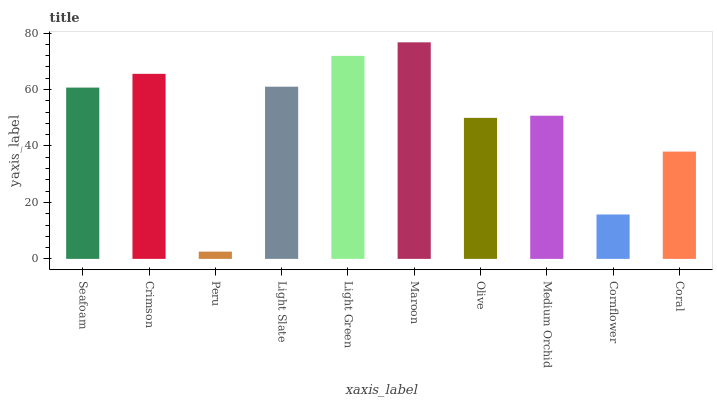Is Peru the minimum?
Answer yes or no. Yes. Is Maroon the maximum?
Answer yes or no. Yes. Is Crimson the minimum?
Answer yes or no. No. Is Crimson the maximum?
Answer yes or no. No. Is Crimson greater than Seafoam?
Answer yes or no. Yes. Is Seafoam less than Crimson?
Answer yes or no. Yes. Is Seafoam greater than Crimson?
Answer yes or no. No. Is Crimson less than Seafoam?
Answer yes or no. No. Is Seafoam the high median?
Answer yes or no. Yes. Is Medium Orchid the low median?
Answer yes or no. Yes. Is Maroon the high median?
Answer yes or no. No. Is Coral the low median?
Answer yes or no. No. 